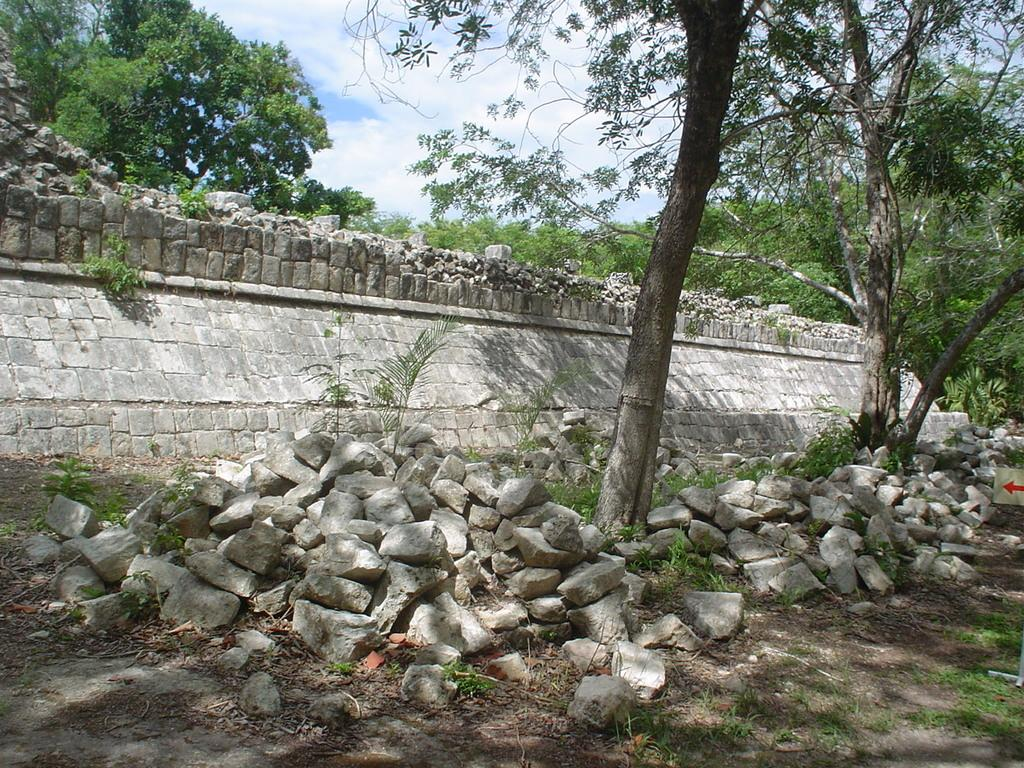What is located at the front of the image? There are trees in the front of the image. What is situated on either side of the trees? There are rocks on either side of the trees. What can be seen in the background of the image? There is a wall in the background of the image. What is visible behind the wall? There are many trees behind the wall. What is visible above the wall? The sky is visible above the wall. What can be observed in the sky? Clouds are present in the sky. Where is the seat located in the image? There is no seat present in the image. What type of fruit can be seen hanging from the trees in the image? There is no fruit visible in the image; only trees, rocks, a wall, and the sky are present. 